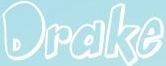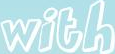What text is displayed in these images sequentially, separated by a semicolon? Drake; with 